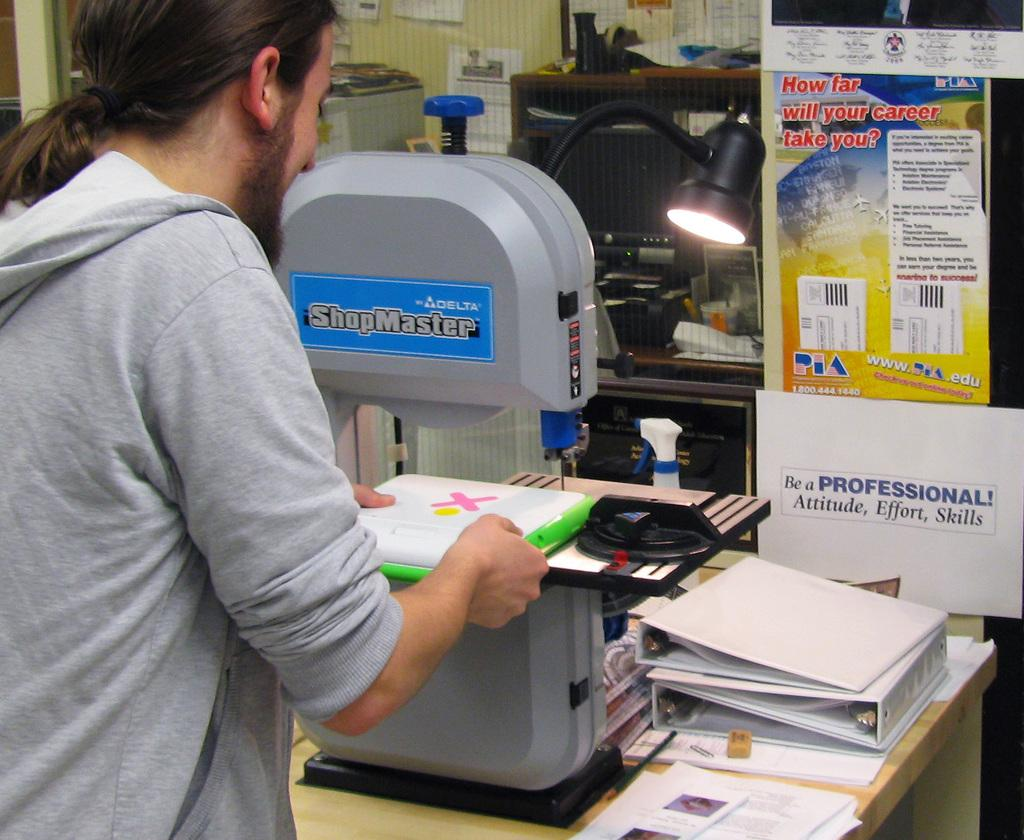<image>
Describe the image concisely. A man uses the shopmaster machine to cut something. 